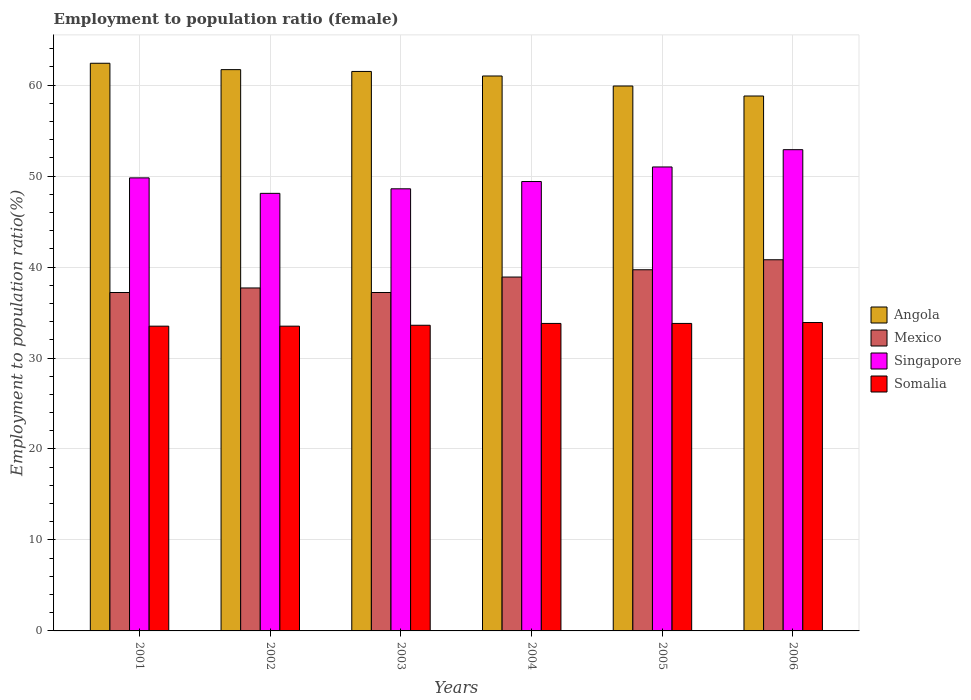How many different coloured bars are there?
Make the answer very short. 4. How many groups of bars are there?
Offer a very short reply. 6. Are the number of bars per tick equal to the number of legend labels?
Your answer should be compact. Yes. How many bars are there on the 6th tick from the left?
Provide a succinct answer. 4. How many bars are there on the 2nd tick from the right?
Your answer should be very brief. 4. What is the label of the 2nd group of bars from the left?
Your response must be concise. 2002. In how many cases, is the number of bars for a given year not equal to the number of legend labels?
Your answer should be very brief. 0. What is the employment to population ratio in Somalia in 2003?
Provide a succinct answer. 33.6. Across all years, what is the maximum employment to population ratio in Somalia?
Offer a very short reply. 33.9. Across all years, what is the minimum employment to population ratio in Angola?
Make the answer very short. 58.8. In which year was the employment to population ratio in Somalia maximum?
Your answer should be compact. 2006. In which year was the employment to population ratio in Somalia minimum?
Offer a terse response. 2001. What is the total employment to population ratio in Angola in the graph?
Your response must be concise. 365.3. What is the difference between the employment to population ratio in Angola in 2001 and that in 2006?
Provide a succinct answer. 3.6. What is the difference between the employment to population ratio in Angola in 2001 and the employment to population ratio in Somalia in 2004?
Give a very brief answer. 28.6. What is the average employment to population ratio in Singapore per year?
Ensure brevity in your answer.  49.97. In the year 2004, what is the difference between the employment to population ratio in Somalia and employment to population ratio in Angola?
Your answer should be very brief. -27.2. In how many years, is the employment to population ratio in Mexico greater than 8 %?
Provide a short and direct response. 6. What is the ratio of the employment to population ratio in Angola in 2001 to that in 2005?
Keep it short and to the point. 1.04. Is the employment to population ratio in Angola in 2001 less than that in 2006?
Make the answer very short. No. What is the difference between the highest and the second highest employment to population ratio in Mexico?
Give a very brief answer. 1.1. What is the difference between the highest and the lowest employment to population ratio in Angola?
Provide a short and direct response. 3.6. Is the sum of the employment to population ratio in Singapore in 2002 and 2004 greater than the maximum employment to population ratio in Mexico across all years?
Make the answer very short. Yes. Is it the case that in every year, the sum of the employment to population ratio in Somalia and employment to population ratio in Angola is greater than the employment to population ratio in Mexico?
Your answer should be compact. Yes. Are the values on the major ticks of Y-axis written in scientific E-notation?
Your answer should be compact. No. Does the graph contain grids?
Make the answer very short. Yes. How are the legend labels stacked?
Give a very brief answer. Vertical. What is the title of the graph?
Make the answer very short. Employment to population ratio (female). What is the label or title of the X-axis?
Make the answer very short. Years. What is the label or title of the Y-axis?
Keep it short and to the point. Employment to population ratio(%). What is the Employment to population ratio(%) of Angola in 2001?
Provide a succinct answer. 62.4. What is the Employment to population ratio(%) in Mexico in 2001?
Make the answer very short. 37.2. What is the Employment to population ratio(%) of Singapore in 2001?
Your response must be concise. 49.8. What is the Employment to population ratio(%) in Somalia in 2001?
Your answer should be compact. 33.5. What is the Employment to population ratio(%) in Angola in 2002?
Your response must be concise. 61.7. What is the Employment to population ratio(%) in Mexico in 2002?
Ensure brevity in your answer.  37.7. What is the Employment to population ratio(%) in Singapore in 2002?
Provide a succinct answer. 48.1. What is the Employment to population ratio(%) in Somalia in 2002?
Offer a very short reply. 33.5. What is the Employment to population ratio(%) of Angola in 2003?
Offer a very short reply. 61.5. What is the Employment to population ratio(%) in Mexico in 2003?
Offer a terse response. 37.2. What is the Employment to population ratio(%) in Singapore in 2003?
Offer a very short reply. 48.6. What is the Employment to population ratio(%) of Somalia in 2003?
Provide a succinct answer. 33.6. What is the Employment to population ratio(%) of Mexico in 2004?
Your answer should be compact. 38.9. What is the Employment to population ratio(%) of Singapore in 2004?
Give a very brief answer. 49.4. What is the Employment to population ratio(%) of Somalia in 2004?
Provide a short and direct response. 33.8. What is the Employment to population ratio(%) of Angola in 2005?
Make the answer very short. 59.9. What is the Employment to population ratio(%) of Mexico in 2005?
Provide a short and direct response. 39.7. What is the Employment to population ratio(%) of Somalia in 2005?
Keep it short and to the point. 33.8. What is the Employment to population ratio(%) in Angola in 2006?
Ensure brevity in your answer.  58.8. What is the Employment to population ratio(%) of Mexico in 2006?
Your answer should be compact. 40.8. What is the Employment to population ratio(%) in Singapore in 2006?
Provide a succinct answer. 52.9. What is the Employment to population ratio(%) of Somalia in 2006?
Your response must be concise. 33.9. Across all years, what is the maximum Employment to population ratio(%) in Angola?
Your answer should be very brief. 62.4. Across all years, what is the maximum Employment to population ratio(%) in Mexico?
Ensure brevity in your answer.  40.8. Across all years, what is the maximum Employment to population ratio(%) of Singapore?
Provide a succinct answer. 52.9. Across all years, what is the maximum Employment to population ratio(%) in Somalia?
Offer a very short reply. 33.9. Across all years, what is the minimum Employment to population ratio(%) in Angola?
Provide a succinct answer. 58.8. Across all years, what is the minimum Employment to population ratio(%) of Mexico?
Your response must be concise. 37.2. Across all years, what is the minimum Employment to population ratio(%) in Singapore?
Give a very brief answer. 48.1. Across all years, what is the minimum Employment to population ratio(%) in Somalia?
Your answer should be very brief. 33.5. What is the total Employment to population ratio(%) of Angola in the graph?
Provide a short and direct response. 365.3. What is the total Employment to population ratio(%) in Mexico in the graph?
Ensure brevity in your answer.  231.5. What is the total Employment to population ratio(%) of Singapore in the graph?
Your answer should be compact. 299.8. What is the total Employment to population ratio(%) of Somalia in the graph?
Offer a terse response. 202.1. What is the difference between the Employment to population ratio(%) of Mexico in 2001 and that in 2002?
Your answer should be very brief. -0.5. What is the difference between the Employment to population ratio(%) of Singapore in 2001 and that in 2002?
Provide a short and direct response. 1.7. What is the difference between the Employment to population ratio(%) of Somalia in 2001 and that in 2002?
Make the answer very short. 0. What is the difference between the Employment to population ratio(%) in Angola in 2001 and that in 2003?
Your answer should be compact. 0.9. What is the difference between the Employment to population ratio(%) in Singapore in 2001 and that in 2003?
Your answer should be compact. 1.2. What is the difference between the Employment to population ratio(%) of Somalia in 2001 and that in 2003?
Offer a very short reply. -0.1. What is the difference between the Employment to population ratio(%) of Singapore in 2001 and that in 2004?
Give a very brief answer. 0.4. What is the difference between the Employment to population ratio(%) of Somalia in 2001 and that in 2004?
Provide a short and direct response. -0.3. What is the difference between the Employment to population ratio(%) in Angola in 2001 and that in 2005?
Offer a very short reply. 2.5. What is the difference between the Employment to population ratio(%) in Mexico in 2001 and that in 2005?
Your answer should be very brief. -2.5. What is the difference between the Employment to population ratio(%) in Angola in 2001 and that in 2006?
Your answer should be compact. 3.6. What is the difference between the Employment to population ratio(%) in Mexico in 2001 and that in 2006?
Your response must be concise. -3.6. What is the difference between the Employment to population ratio(%) in Angola in 2002 and that in 2003?
Provide a short and direct response. 0.2. What is the difference between the Employment to population ratio(%) in Mexico in 2002 and that in 2003?
Your response must be concise. 0.5. What is the difference between the Employment to population ratio(%) of Singapore in 2002 and that in 2003?
Offer a terse response. -0.5. What is the difference between the Employment to population ratio(%) in Angola in 2002 and that in 2004?
Your answer should be compact. 0.7. What is the difference between the Employment to population ratio(%) of Somalia in 2002 and that in 2004?
Give a very brief answer. -0.3. What is the difference between the Employment to population ratio(%) in Angola in 2002 and that in 2005?
Your answer should be compact. 1.8. What is the difference between the Employment to population ratio(%) in Mexico in 2002 and that in 2005?
Give a very brief answer. -2. What is the difference between the Employment to population ratio(%) of Singapore in 2002 and that in 2005?
Offer a terse response. -2.9. What is the difference between the Employment to population ratio(%) in Somalia in 2002 and that in 2005?
Provide a succinct answer. -0.3. What is the difference between the Employment to population ratio(%) of Mexico in 2002 and that in 2006?
Your response must be concise. -3.1. What is the difference between the Employment to population ratio(%) of Singapore in 2002 and that in 2006?
Your answer should be very brief. -4.8. What is the difference between the Employment to population ratio(%) of Angola in 2003 and that in 2004?
Ensure brevity in your answer.  0.5. What is the difference between the Employment to population ratio(%) in Singapore in 2003 and that in 2004?
Give a very brief answer. -0.8. What is the difference between the Employment to population ratio(%) in Mexico in 2003 and that in 2005?
Your answer should be very brief. -2.5. What is the difference between the Employment to population ratio(%) in Somalia in 2003 and that in 2005?
Ensure brevity in your answer.  -0.2. What is the difference between the Employment to population ratio(%) in Angola in 2003 and that in 2006?
Provide a succinct answer. 2.7. What is the difference between the Employment to population ratio(%) in Mexico in 2003 and that in 2006?
Provide a succinct answer. -3.6. What is the difference between the Employment to population ratio(%) of Singapore in 2003 and that in 2006?
Your response must be concise. -4.3. What is the difference between the Employment to population ratio(%) in Somalia in 2003 and that in 2006?
Your answer should be very brief. -0.3. What is the difference between the Employment to population ratio(%) in Mexico in 2004 and that in 2005?
Ensure brevity in your answer.  -0.8. What is the difference between the Employment to population ratio(%) of Singapore in 2004 and that in 2005?
Provide a succinct answer. -1.6. What is the difference between the Employment to population ratio(%) of Angola in 2001 and the Employment to population ratio(%) of Mexico in 2002?
Offer a terse response. 24.7. What is the difference between the Employment to population ratio(%) of Angola in 2001 and the Employment to population ratio(%) of Somalia in 2002?
Keep it short and to the point. 28.9. What is the difference between the Employment to population ratio(%) in Mexico in 2001 and the Employment to population ratio(%) in Singapore in 2002?
Provide a short and direct response. -10.9. What is the difference between the Employment to population ratio(%) of Singapore in 2001 and the Employment to population ratio(%) of Somalia in 2002?
Provide a succinct answer. 16.3. What is the difference between the Employment to population ratio(%) in Angola in 2001 and the Employment to population ratio(%) in Mexico in 2003?
Your response must be concise. 25.2. What is the difference between the Employment to population ratio(%) of Angola in 2001 and the Employment to population ratio(%) of Singapore in 2003?
Provide a succinct answer. 13.8. What is the difference between the Employment to population ratio(%) of Angola in 2001 and the Employment to population ratio(%) of Somalia in 2003?
Keep it short and to the point. 28.8. What is the difference between the Employment to population ratio(%) of Mexico in 2001 and the Employment to population ratio(%) of Singapore in 2003?
Make the answer very short. -11.4. What is the difference between the Employment to population ratio(%) of Angola in 2001 and the Employment to population ratio(%) of Mexico in 2004?
Provide a short and direct response. 23.5. What is the difference between the Employment to population ratio(%) in Angola in 2001 and the Employment to population ratio(%) in Singapore in 2004?
Ensure brevity in your answer.  13. What is the difference between the Employment to population ratio(%) of Angola in 2001 and the Employment to population ratio(%) of Somalia in 2004?
Your answer should be compact. 28.6. What is the difference between the Employment to population ratio(%) of Mexico in 2001 and the Employment to population ratio(%) of Singapore in 2004?
Provide a short and direct response. -12.2. What is the difference between the Employment to population ratio(%) of Mexico in 2001 and the Employment to population ratio(%) of Somalia in 2004?
Provide a succinct answer. 3.4. What is the difference between the Employment to population ratio(%) in Angola in 2001 and the Employment to population ratio(%) in Mexico in 2005?
Ensure brevity in your answer.  22.7. What is the difference between the Employment to population ratio(%) of Angola in 2001 and the Employment to population ratio(%) of Singapore in 2005?
Your answer should be compact. 11.4. What is the difference between the Employment to population ratio(%) of Angola in 2001 and the Employment to population ratio(%) of Somalia in 2005?
Your answer should be very brief. 28.6. What is the difference between the Employment to population ratio(%) in Mexico in 2001 and the Employment to population ratio(%) in Somalia in 2005?
Your response must be concise. 3.4. What is the difference between the Employment to population ratio(%) of Singapore in 2001 and the Employment to population ratio(%) of Somalia in 2005?
Keep it short and to the point. 16. What is the difference between the Employment to population ratio(%) in Angola in 2001 and the Employment to population ratio(%) in Mexico in 2006?
Your response must be concise. 21.6. What is the difference between the Employment to population ratio(%) of Angola in 2001 and the Employment to population ratio(%) of Singapore in 2006?
Provide a short and direct response. 9.5. What is the difference between the Employment to population ratio(%) in Mexico in 2001 and the Employment to population ratio(%) in Singapore in 2006?
Ensure brevity in your answer.  -15.7. What is the difference between the Employment to population ratio(%) of Singapore in 2001 and the Employment to population ratio(%) of Somalia in 2006?
Provide a short and direct response. 15.9. What is the difference between the Employment to population ratio(%) in Angola in 2002 and the Employment to population ratio(%) in Singapore in 2003?
Your answer should be very brief. 13.1. What is the difference between the Employment to population ratio(%) of Angola in 2002 and the Employment to population ratio(%) of Somalia in 2003?
Your answer should be very brief. 28.1. What is the difference between the Employment to population ratio(%) of Mexico in 2002 and the Employment to population ratio(%) of Singapore in 2003?
Provide a short and direct response. -10.9. What is the difference between the Employment to population ratio(%) in Mexico in 2002 and the Employment to population ratio(%) in Somalia in 2003?
Your answer should be compact. 4.1. What is the difference between the Employment to population ratio(%) of Singapore in 2002 and the Employment to population ratio(%) of Somalia in 2003?
Offer a very short reply. 14.5. What is the difference between the Employment to population ratio(%) in Angola in 2002 and the Employment to population ratio(%) in Mexico in 2004?
Your answer should be compact. 22.8. What is the difference between the Employment to population ratio(%) in Angola in 2002 and the Employment to population ratio(%) in Singapore in 2004?
Offer a very short reply. 12.3. What is the difference between the Employment to population ratio(%) of Angola in 2002 and the Employment to population ratio(%) of Somalia in 2004?
Offer a terse response. 27.9. What is the difference between the Employment to population ratio(%) in Mexico in 2002 and the Employment to population ratio(%) in Singapore in 2004?
Offer a very short reply. -11.7. What is the difference between the Employment to population ratio(%) in Singapore in 2002 and the Employment to population ratio(%) in Somalia in 2004?
Make the answer very short. 14.3. What is the difference between the Employment to population ratio(%) in Angola in 2002 and the Employment to population ratio(%) in Singapore in 2005?
Offer a very short reply. 10.7. What is the difference between the Employment to population ratio(%) in Angola in 2002 and the Employment to population ratio(%) in Somalia in 2005?
Offer a terse response. 27.9. What is the difference between the Employment to population ratio(%) of Mexico in 2002 and the Employment to population ratio(%) of Somalia in 2005?
Offer a terse response. 3.9. What is the difference between the Employment to population ratio(%) of Singapore in 2002 and the Employment to population ratio(%) of Somalia in 2005?
Give a very brief answer. 14.3. What is the difference between the Employment to population ratio(%) of Angola in 2002 and the Employment to population ratio(%) of Mexico in 2006?
Give a very brief answer. 20.9. What is the difference between the Employment to population ratio(%) of Angola in 2002 and the Employment to population ratio(%) of Somalia in 2006?
Provide a succinct answer. 27.8. What is the difference between the Employment to population ratio(%) of Mexico in 2002 and the Employment to population ratio(%) of Singapore in 2006?
Offer a terse response. -15.2. What is the difference between the Employment to population ratio(%) of Angola in 2003 and the Employment to population ratio(%) of Mexico in 2004?
Offer a very short reply. 22.6. What is the difference between the Employment to population ratio(%) of Angola in 2003 and the Employment to population ratio(%) of Singapore in 2004?
Provide a short and direct response. 12.1. What is the difference between the Employment to population ratio(%) of Angola in 2003 and the Employment to population ratio(%) of Somalia in 2004?
Provide a short and direct response. 27.7. What is the difference between the Employment to population ratio(%) of Mexico in 2003 and the Employment to population ratio(%) of Singapore in 2004?
Your answer should be very brief. -12.2. What is the difference between the Employment to population ratio(%) in Mexico in 2003 and the Employment to population ratio(%) in Somalia in 2004?
Offer a terse response. 3.4. What is the difference between the Employment to population ratio(%) in Angola in 2003 and the Employment to population ratio(%) in Mexico in 2005?
Your answer should be compact. 21.8. What is the difference between the Employment to population ratio(%) of Angola in 2003 and the Employment to population ratio(%) of Somalia in 2005?
Offer a very short reply. 27.7. What is the difference between the Employment to population ratio(%) in Mexico in 2003 and the Employment to population ratio(%) in Singapore in 2005?
Provide a succinct answer. -13.8. What is the difference between the Employment to population ratio(%) in Singapore in 2003 and the Employment to population ratio(%) in Somalia in 2005?
Your answer should be compact. 14.8. What is the difference between the Employment to population ratio(%) in Angola in 2003 and the Employment to population ratio(%) in Mexico in 2006?
Your response must be concise. 20.7. What is the difference between the Employment to population ratio(%) of Angola in 2003 and the Employment to population ratio(%) of Singapore in 2006?
Ensure brevity in your answer.  8.6. What is the difference between the Employment to population ratio(%) in Angola in 2003 and the Employment to population ratio(%) in Somalia in 2006?
Your answer should be very brief. 27.6. What is the difference between the Employment to population ratio(%) of Mexico in 2003 and the Employment to population ratio(%) of Singapore in 2006?
Make the answer very short. -15.7. What is the difference between the Employment to population ratio(%) of Angola in 2004 and the Employment to population ratio(%) of Mexico in 2005?
Provide a short and direct response. 21.3. What is the difference between the Employment to population ratio(%) in Angola in 2004 and the Employment to population ratio(%) in Singapore in 2005?
Your answer should be very brief. 10. What is the difference between the Employment to population ratio(%) of Angola in 2004 and the Employment to population ratio(%) of Somalia in 2005?
Your answer should be compact. 27.2. What is the difference between the Employment to population ratio(%) in Singapore in 2004 and the Employment to population ratio(%) in Somalia in 2005?
Make the answer very short. 15.6. What is the difference between the Employment to population ratio(%) of Angola in 2004 and the Employment to population ratio(%) of Mexico in 2006?
Offer a very short reply. 20.2. What is the difference between the Employment to population ratio(%) of Angola in 2004 and the Employment to population ratio(%) of Somalia in 2006?
Keep it short and to the point. 27.1. What is the difference between the Employment to population ratio(%) in Mexico in 2004 and the Employment to population ratio(%) in Somalia in 2006?
Your response must be concise. 5. What is the difference between the Employment to population ratio(%) in Angola in 2005 and the Employment to population ratio(%) in Singapore in 2006?
Ensure brevity in your answer.  7. What is the difference between the Employment to population ratio(%) of Angola in 2005 and the Employment to population ratio(%) of Somalia in 2006?
Provide a short and direct response. 26. What is the difference between the Employment to population ratio(%) of Mexico in 2005 and the Employment to population ratio(%) of Singapore in 2006?
Your answer should be compact. -13.2. What is the average Employment to population ratio(%) in Angola per year?
Keep it short and to the point. 60.88. What is the average Employment to population ratio(%) in Mexico per year?
Offer a terse response. 38.58. What is the average Employment to population ratio(%) of Singapore per year?
Your response must be concise. 49.97. What is the average Employment to population ratio(%) in Somalia per year?
Your answer should be very brief. 33.68. In the year 2001, what is the difference between the Employment to population ratio(%) in Angola and Employment to population ratio(%) in Mexico?
Your answer should be compact. 25.2. In the year 2001, what is the difference between the Employment to population ratio(%) of Angola and Employment to population ratio(%) of Somalia?
Ensure brevity in your answer.  28.9. In the year 2001, what is the difference between the Employment to population ratio(%) in Singapore and Employment to population ratio(%) in Somalia?
Provide a succinct answer. 16.3. In the year 2002, what is the difference between the Employment to population ratio(%) in Angola and Employment to population ratio(%) in Mexico?
Keep it short and to the point. 24. In the year 2002, what is the difference between the Employment to population ratio(%) of Angola and Employment to population ratio(%) of Singapore?
Provide a short and direct response. 13.6. In the year 2002, what is the difference between the Employment to population ratio(%) of Angola and Employment to population ratio(%) of Somalia?
Offer a very short reply. 28.2. In the year 2002, what is the difference between the Employment to population ratio(%) of Mexico and Employment to population ratio(%) of Singapore?
Your answer should be compact. -10.4. In the year 2003, what is the difference between the Employment to population ratio(%) in Angola and Employment to population ratio(%) in Mexico?
Ensure brevity in your answer.  24.3. In the year 2003, what is the difference between the Employment to population ratio(%) in Angola and Employment to population ratio(%) in Singapore?
Your response must be concise. 12.9. In the year 2003, what is the difference between the Employment to population ratio(%) in Angola and Employment to population ratio(%) in Somalia?
Make the answer very short. 27.9. In the year 2003, what is the difference between the Employment to population ratio(%) of Mexico and Employment to population ratio(%) of Singapore?
Give a very brief answer. -11.4. In the year 2003, what is the difference between the Employment to population ratio(%) of Mexico and Employment to population ratio(%) of Somalia?
Ensure brevity in your answer.  3.6. In the year 2003, what is the difference between the Employment to population ratio(%) of Singapore and Employment to population ratio(%) of Somalia?
Make the answer very short. 15. In the year 2004, what is the difference between the Employment to population ratio(%) in Angola and Employment to population ratio(%) in Mexico?
Give a very brief answer. 22.1. In the year 2004, what is the difference between the Employment to population ratio(%) of Angola and Employment to population ratio(%) of Somalia?
Your response must be concise. 27.2. In the year 2004, what is the difference between the Employment to population ratio(%) of Mexico and Employment to population ratio(%) of Singapore?
Offer a very short reply. -10.5. In the year 2005, what is the difference between the Employment to population ratio(%) in Angola and Employment to population ratio(%) in Mexico?
Your answer should be very brief. 20.2. In the year 2005, what is the difference between the Employment to population ratio(%) in Angola and Employment to population ratio(%) in Singapore?
Provide a short and direct response. 8.9. In the year 2005, what is the difference between the Employment to population ratio(%) of Angola and Employment to population ratio(%) of Somalia?
Provide a succinct answer. 26.1. In the year 2005, what is the difference between the Employment to population ratio(%) of Mexico and Employment to population ratio(%) of Singapore?
Make the answer very short. -11.3. In the year 2005, what is the difference between the Employment to population ratio(%) of Mexico and Employment to population ratio(%) of Somalia?
Ensure brevity in your answer.  5.9. In the year 2005, what is the difference between the Employment to population ratio(%) of Singapore and Employment to population ratio(%) of Somalia?
Your response must be concise. 17.2. In the year 2006, what is the difference between the Employment to population ratio(%) of Angola and Employment to population ratio(%) of Singapore?
Offer a terse response. 5.9. In the year 2006, what is the difference between the Employment to population ratio(%) of Angola and Employment to population ratio(%) of Somalia?
Your answer should be very brief. 24.9. In the year 2006, what is the difference between the Employment to population ratio(%) of Singapore and Employment to population ratio(%) of Somalia?
Provide a short and direct response. 19. What is the ratio of the Employment to population ratio(%) of Angola in 2001 to that in 2002?
Your answer should be very brief. 1.01. What is the ratio of the Employment to population ratio(%) of Mexico in 2001 to that in 2002?
Give a very brief answer. 0.99. What is the ratio of the Employment to population ratio(%) in Singapore in 2001 to that in 2002?
Offer a very short reply. 1.04. What is the ratio of the Employment to population ratio(%) in Somalia in 2001 to that in 2002?
Keep it short and to the point. 1. What is the ratio of the Employment to population ratio(%) in Angola in 2001 to that in 2003?
Offer a terse response. 1.01. What is the ratio of the Employment to population ratio(%) in Mexico in 2001 to that in 2003?
Your answer should be compact. 1. What is the ratio of the Employment to population ratio(%) of Singapore in 2001 to that in 2003?
Ensure brevity in your answer.  1.02. What is the ratio of the Employment to population ratio(%) of Somalia in 2001 to that in 2003?
Make the answer very short. 1. What is the ratio of the Employment to population ratio(%) of Mexico in 2001 to that in 2004?
Keep it short and to the point. 0.96. What is the ratio of the Employment to population ratio(%) of Angola in 2001 to that in 2005?
Offer a terse response. 1.04. What is the ratio of the Employment to population ratio(%) in Mexico in 2001 to that in 2005?
Your response must be concise. 0.94. What is the ratio of the Employment to population ratio(%) in Singapore in 2001 to that in 2005?
Give a very brief answer. 0.98. What is the ratio of the Employment to population ratio(%) in Angola in 2001 to that in 2006?
Make the answer very short. 1.06. What is the ratio of the Employment to population ratio(%) in Mexico in 2001 to that in 2006?
Offer a very short reply. 0.91. What is the ratio of the Employment to population ratio(%) of Singapore in 2001 to that in 2006?
Offer a very short reply. 0.94. What is the ratio of the Employment to population ratio(%) in Somalia in 2001 to that in 2006?
Make the answer very short. 0.99. What is the ratio of the Employment to population ratio(%) in Angola in 2002 to that in 2003?
Offer a very short reply. 1. What is the ratio of the Employment to population ratio(%) in Mexico in 2002 to that in 2003?
Keep it short and to the point. 1.01. What is the ratio of the Employment to population ratio(%) of Angola in 2002 to that in 2004?
Your answer should be compact. 1.01. What is the ratio of the Employment to population ratio(%) in Mexico in 2002 to that in 2004?
Your answer should be very brief. 0.97. What is the ratio of the Employment to population ratio(%) of Singapore in 2002 to that in 2004?
Give a very brief answer. 0.97. What is the ratio of the Employment to population ratio(%) in Somalia in 2002 to that in 2004?
Provide a succinct answer. 0.99. What is the ratio of the Employment to population ratio(%) in Angola in 2002 to that in 2005?
Offer a very short reply. 1.03. What is the ratio of the Employment to population ratio(%) of Mexico in 2002 to that in 2005?
Make the answer very short. 0.95. What is the ratio of the Employment to population ratio(%) in Singapore in 2002 to that in 2005?
Your response must be concise. 0.94. What is the ratio of the Employment to population ratio(%) in Somalia in 2002 to that in 2005?
Provide a short and direct response. 0.99. What is the ratio of the Employment to population ratio(%) of Angola in 2002 to that in 2006?
Make the answer very short. 1.05. What is the ratio of the Employment to population ratio(%) in Mexico in 2002 to that in 2006?
Give a very brief answer. 0.92. What is the ratio of the Employment to population ratio(%) in Singapore in 2002 to that in 2006?
Provide a succinct answer. 0.91. What is the ratio of the Employment to population ratio(%) of Angola in 2003 to that in 2004?
Keep it short and to the point. 1.01. What is the ratio of the Employment to population ratio(%) of Mexico in 2003 to that in 2004?
Your answer should be very brief. 0.96. What is the ratio of the Employment to population ratio(%) of Singapore in 2003 to that in 2004?
Ensure brevity in your answer.  0.98. What is the ratio of the Employment to population ratio(%) of Angola in 2003 to that in 2005?
Provide a short and direct response. 1.03. What is the ratio of the Employment to population ratio(%) of Mexico in 2003 to that in 2005?
Your response must be concise. 0.94. What is the ratio of the Employment to population ratio(%) of Singapore in 2003 to that in 2005?
Your response must be concise. 0.95. What is the ratio of the Employment to population ratio(%) of Angola in 2003 to that in 2006?
Give a very brief answer. 1.05. What is the ratio of the Employment to population ratio(%) of Mexico in 2003 to that in 2006?
Make the answer very short. 0.91. What is the ratio of the Employment to population ratio(%) in Singapore in 2003 to that in 2006?
Make the answer very short. 0.92. What is the ratio of the Employment to population ratio(%) in Angola in 2004 to that in 2005?
Give a very brief answer. 1.02. What is the ratio of the Employment to population ratio(%) in Mexico in 2004 to that in 2005?
Offer a very short reply. 0.98. What is the ratio of the Employment to population ratio(%) in Singapore in 2004 to that in 2005?
Your answer should be very brief. 0.97. What is the ratio of the Employment to population ratio(%) in Angola in 2004 to that in 2006?
Offer a very short reply. 1.04. What is the ratio of the Employment to population ratio(%) in Mexico in 2004 to that in 2006?
Give a very brief answer. 0.95. What is the ratio of the Employment to population ratio(%) of Singapore in 2004 to that in 2006?
Keep it short and to the point. 0.93. What is the ratio of the Employment to population ratio(%) in Somalia in 2004 to that in 2006?
Provide a short and direct response. 1. What is the ratio of the Employment to population ratio(%) in Angola in 2005 to that in 2006?
Your response must be concise. 1.02. What is the ratio of the Employment to population ratio(%) in Mexico in 2005 to that in 2006?
Give a very brief answer. 0.97. What is the ratio of the Employment to population ratio(%) of Singapore in 2005 to that in 2006?
Your answer should be compact. 0.96. What is the difference between the highest and the second highest Employment to population ratio(%) in Singapore?
Offer a terse response. 1.9. What is the difference between the highest and the second highest Employment to population ratio(%) in Somalia?
Provide a succinct answer. 0.1. What is the difference between the highest and the lowest Employment to population ratio(%) of Angola?
Provide a short and direct response. 3.6. What is the difference between the highest and the lowest Employment to population ratio(%) in Singapore?
Your answer should be compact. 4.8. 